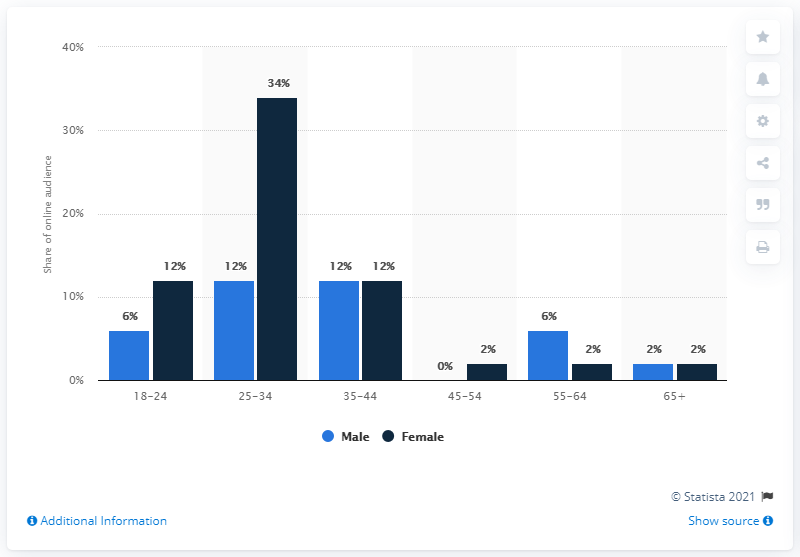What could be the potential implications of this gender imbalance in the workplace? A gender imbalance such as the one noted in the 25-34 age group could have a range of implications, including reduced diversity of thought in the workplace, potential wage gaps, and a possible impact on company culture and team dynamics. Over time, such imbalances could also affect the career progression opportunities available to underrepresented genders.  How might society address the gender gap illustrated in this age group? Addressing the gender gap requires a multi-faceted approach, potentially involving education on implicit bias, implementation of inclusive hiring practices, support for equitable career development programs, and policy-making aimed at eliminating systemic barriers to equal participation across all genders. 